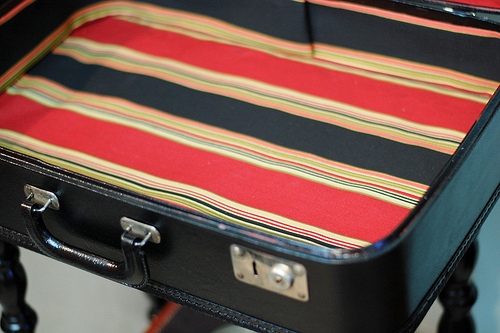<image>
Is there a stripes above the suitcase? No. The stripes is not positioned above the suitcase. The vertical arrangement shows a different relationship. 